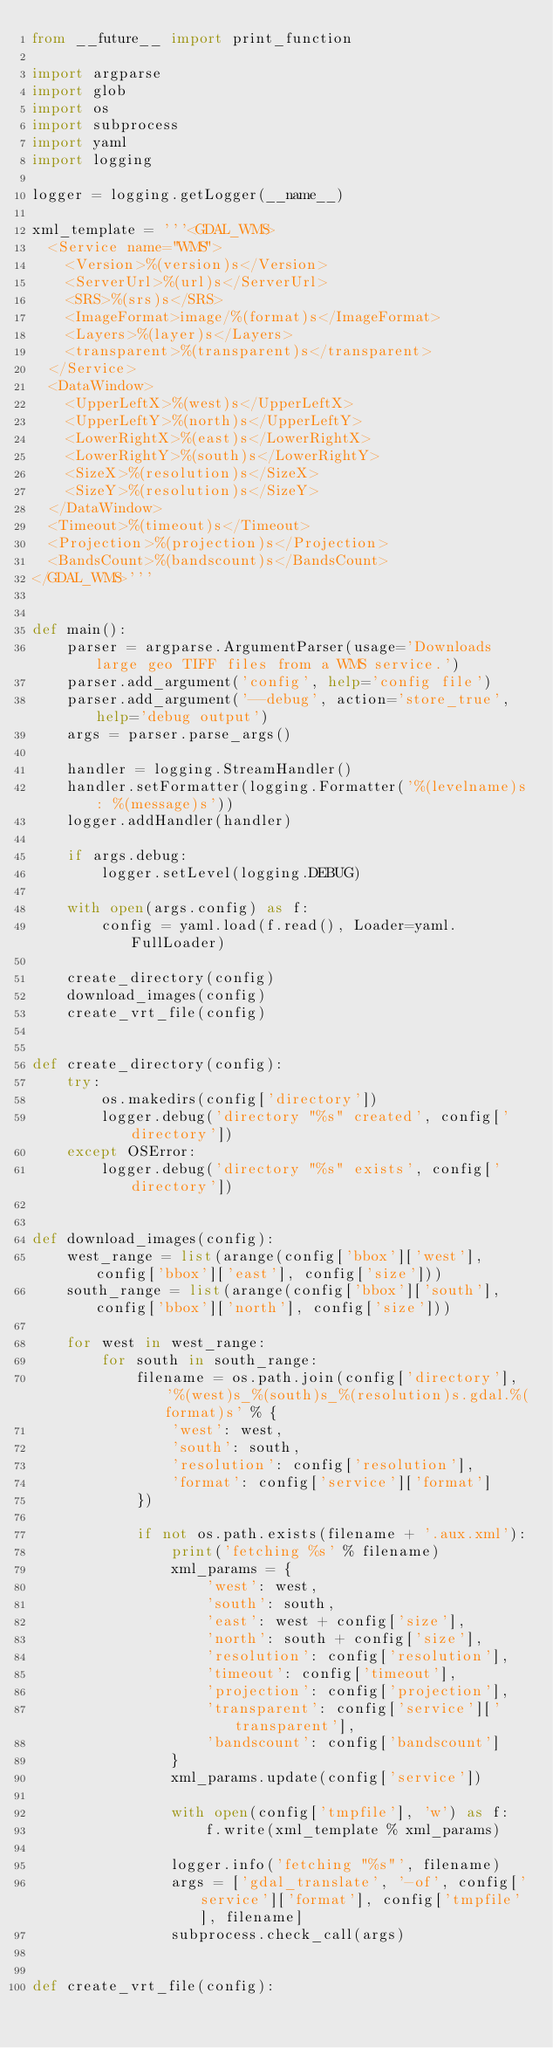Convert code to text. <code><loc_0><loc_0><loc_500><loc_500><_Python_>from __future__ import print_function

import argparse
import glob
import os
import subprocess
import yaml
import logging

logger = logging.getLogger(__name__)

xml_template = '''<GDAL_WMS>
  <Service name="WMS">
    <Version>%(version)s</Version>
    <ServerUrl>%(url)s</ServerUrl>
    <SRS>%(srs)s</SRS>
    <ImageFormat>image/%(format)s</ImageFormat>
    <Layers>%(layer)s</Layers>
    <transparent>%(transparent)s</transparent>
  </Service>
  <DataWindow>
    <UpperLeftX>%(west)s</UpperLeftX>
    <UpperLeftY>%(north)s</UpperLeftY>
    <LowerRightX>%(east)s</LowerRightX>
    <LowerRightY>%(south)s</LowerRightY>
    <SizeX>%(resolution)s</SizeX>
    <SizeY>%(resolution)s</SizeY>
  </DataWindow>
  <Timeout>%(timeout)s</Timeout>
  <Projection>%(projection)s</Projection>
  <BandsCount>%(bandscount)s</BandsCount>
</GDAL_WMS>'''


def main():
    parser = argparse.ArgumentParser(usage='Downloads large geo TIFF files from a WMS service.')
    parser.add_argument('config', help='config file')
    parser.add_argument('--debug', action='store_true', help='debug output')
    args = parser.parse_args()

    handler = logging.StreamHandler()
    handler.setFormatter(logging.Formatter('%(levelname)s: %(message)s'))
    logger.addHandler(handler)

    if args.debug:
        logger.setLevel(logging.DEBUG)

    with open(args.config) as f:
        config = yaml.load(f.read(), Loader=yaml.FullLoader)

    create_directory(config)
    download_images(config)
    create_vrt_file(config)


def create_directory(config):
    try:
        os.makedirs(config['directory'])
        logger.debug('directory "%s" created', config['directory'])
    except OSError:
        logger.debug('directory "%s" exists', config['directory'])


def download_images(config):
    west_range = list(arange(config['bbox']['west'], config['bbox']['east'], config['size']))
    south_range = list(arange(config['bbox']['south'], config['bbox']['north'], config['size']))

    for west in west_range:
        for south in south_range:
            filename = os.path.join(config['directory'], '%(west)s_%(south)s_%(resolution)s.gdal.%(format)s' % {
                'west': west,
                'south': south,
                'resolution': config['resolution'],
                'format': config['service']['format']
            })

            if not os.path.exists(filename + '.aux.xml'):
                print('fetching %s' % filename)
                xml_params = {
                    'west': west,
                    'south': south,
                    'east': west + config['size'],
                    'north': south + config['size'],
                    'resolution': config['resolution'],
                    'timeout': config['timeout'],
                    'projection': config['projection'],
                    'transparent': config['service']['transparent'],
                    'bandscount': config['bandscount']
                }
                xml_params.update(config['service'])

                with open(config['tmpfile'], 'w') as f:
                    f.write(xml_template % xml_params)

                logger.info('fetching "%s"', filename)
                args = ['gdal_translate', '-of', config['service']['format'], config['tmpfile'], filename]
                subprocess.check_call(args)


def create_vrt_file(config):</code> 